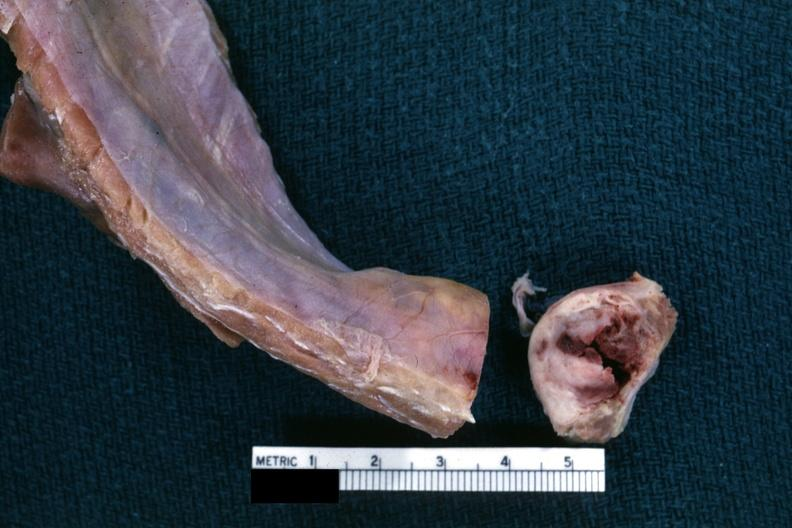what is lesion cross sectioned?
Answer the question using a single word or phrase. To show white neoplasm with central hemorrhage 